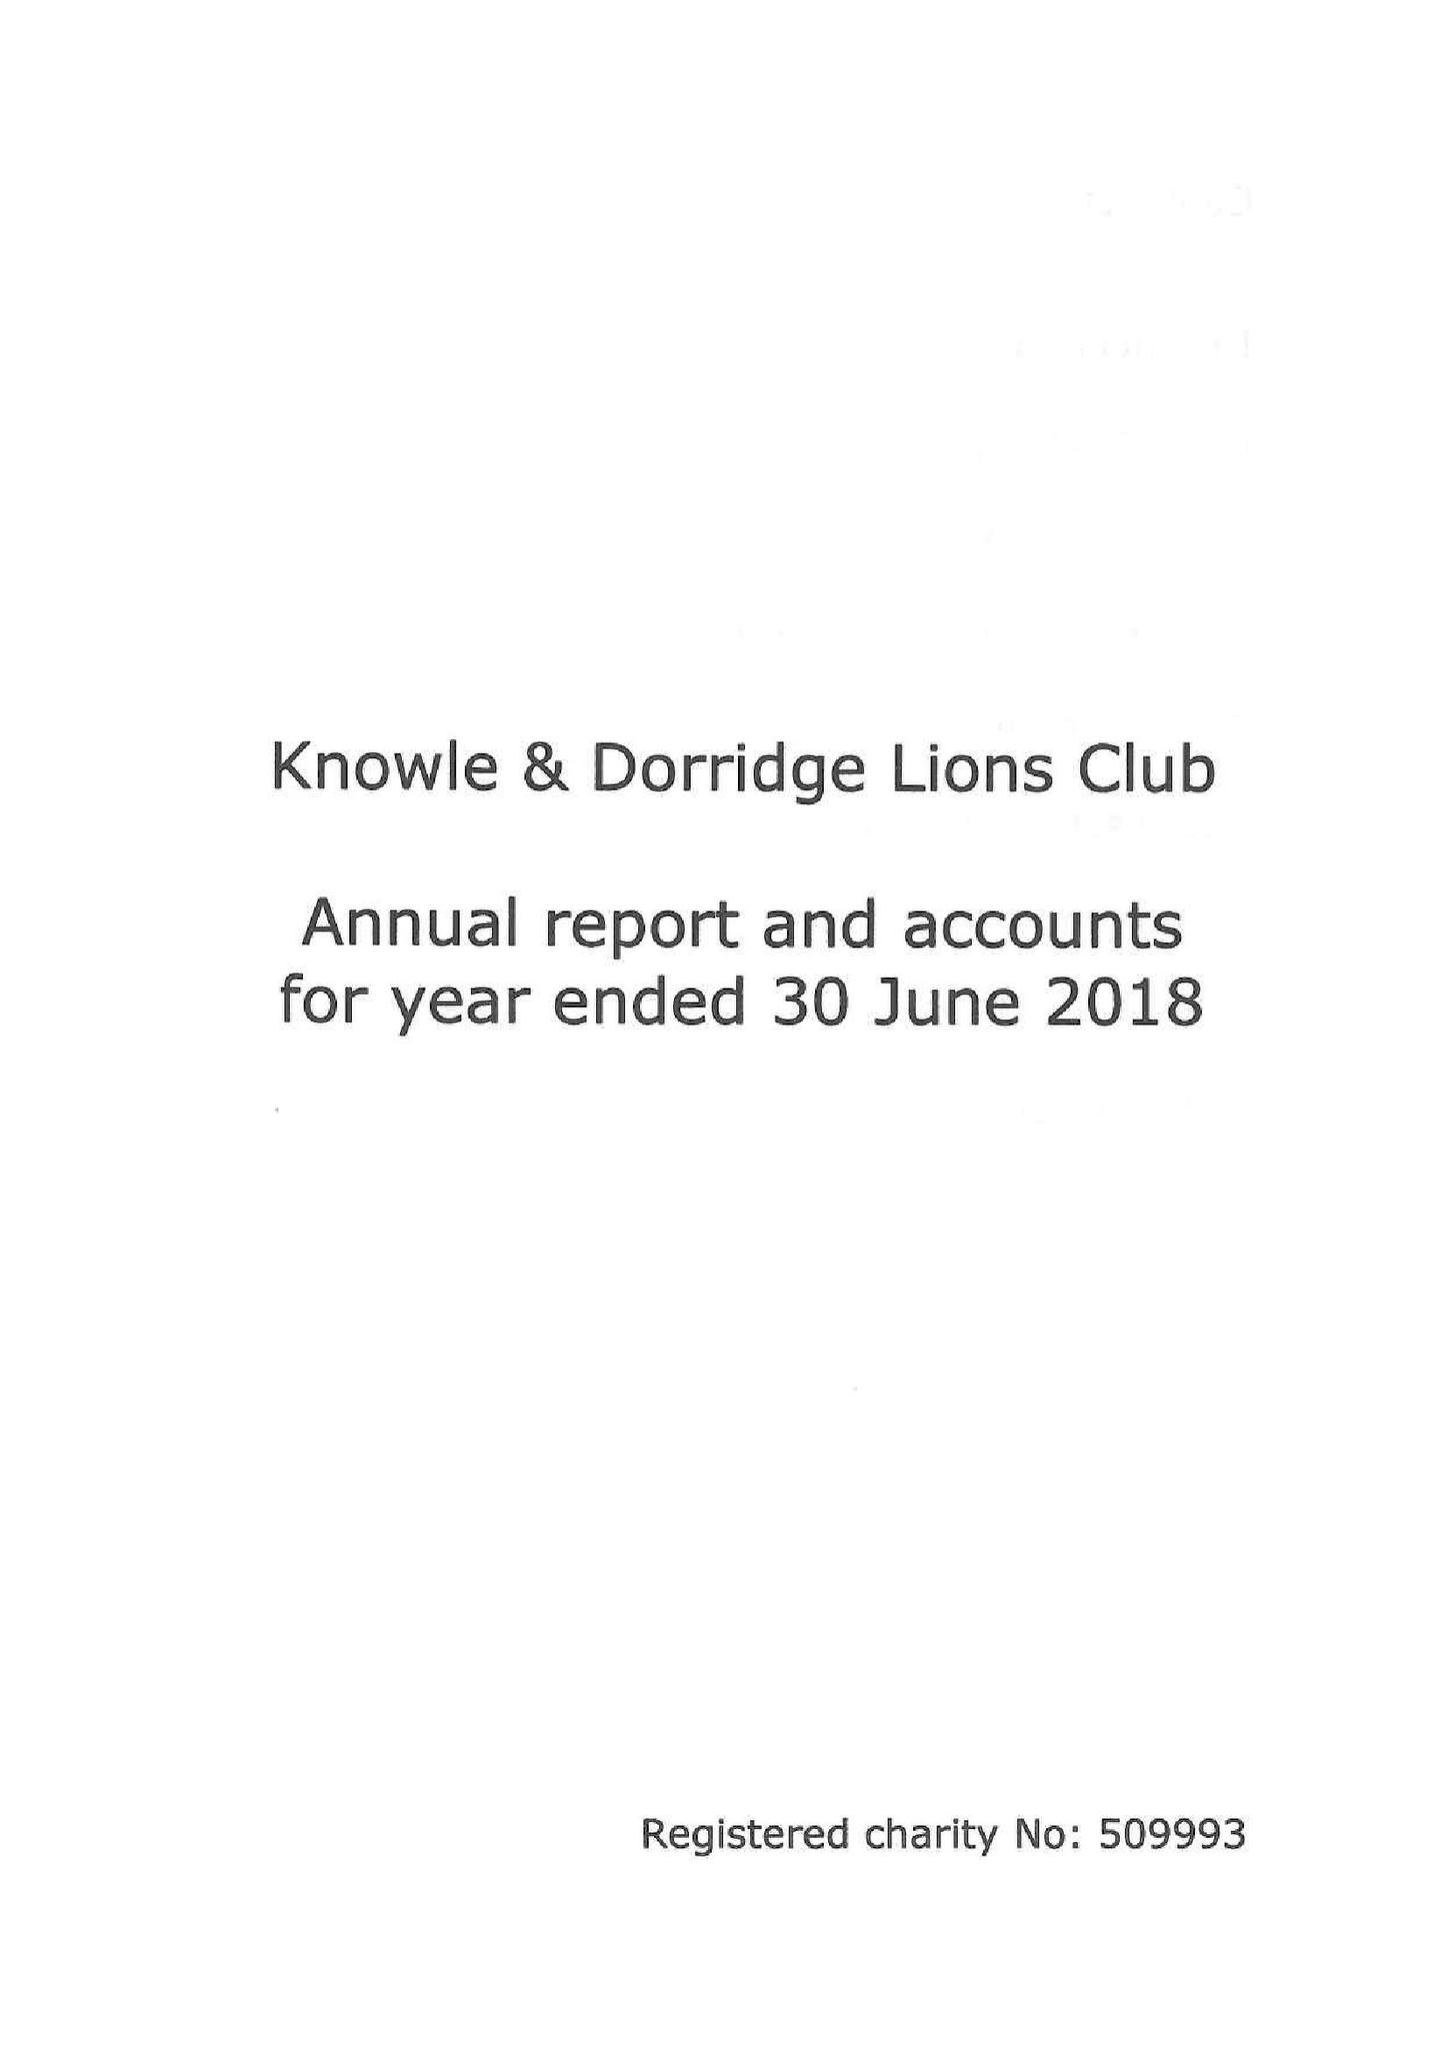What is the value for the charity_number?
Answer the question using a single word or phrase. 509993 